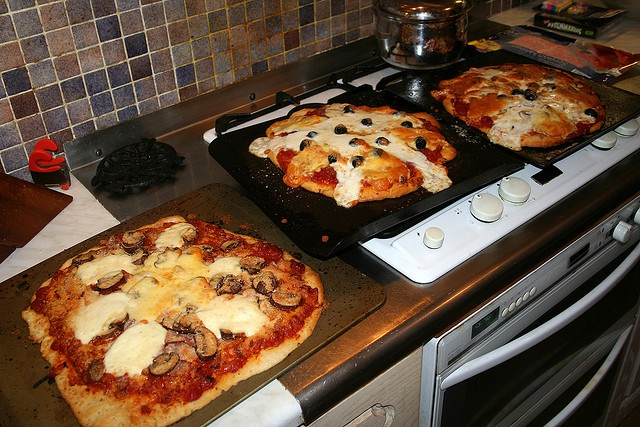Describe the objects in this image and their specific colors. I can see oven in gray, black, darkgray, and lightgray tones, pizza in gray, khaki, maroon, brown, and tan tones, pizza in gray, black, tan, and red tones, pizza in gray, maroon, brown, tan, and black tones, and bowl in gray, black, and maroon tones in this image. 